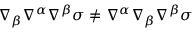<formula> <loc_0><loc_0><loc_500><loc_500>\nabla _ { \beta } \nabla ^ { \alpha } \nabla ^ { \beta } \sigma \neq \nabla ^ { \alpha } \nabla _ { \beta } \nabla ^ { \beta } \sigma</formula> 